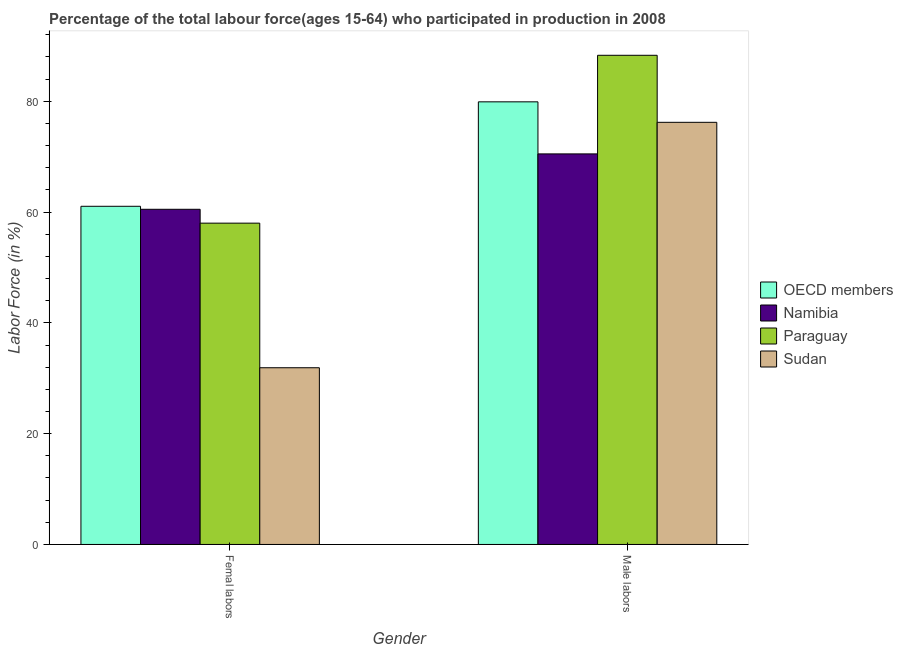How many groups of bars are there?
Provide a succinct answer. 2. Are the number of bars on each tick of the X-axis equal?
Your answer should be very brief. Yes. How many bars are there on the 1st tick from the left?
Ensure brevity in your answer.  4. What is the label of the 1st group of bars from the left?
Make the answer very short. Femal labors. What is the percentage of female labor force in Namibia?
Your response must be concise. 60.5. Across all countries, what is the maximum percentage of male labour force?
Ensure brevity in your answer.  88.3. Across all countries, what is the minimum percentage of female labor force?
Offer a very short reply. 31.9. In which country was the percentage of male labour force maximum?
Make the answer very short. Paraguay. In which country was the percentage of female labor force minimum?
Offer a very short reply. Sudan. What is the total percentage of female labor force in the graph?
Offer a terse response. 211.44. What is the difference between the percentage of male labour force in Namibia and that in OECD members?
Your answer should be very brief. -9.4. What is the difference between the percentage of male labour force in Paraguay and the percentage of female labor force in Namibia?
Your answer should be very brief. 27.8. What is the average percentage of male labour force per country?
Your answer should be compact. 78.72. What is the difference between the percentage of female labor force and percentage of male labour force in Namibia?
Your response must be concise. -10. What is the ratio of the percentage of female labor force in Sudan to that in Namibia?
Provide a succinct answer. 0.53. What does the 4th bar from the left in Male labors represents?
Offer a terse response. Sudan. What does the 3rd bar from the right in Male labors represents?
Ensure brevity in your answer.  Namibia. How many countries are there in the graph?
Provide a short and direct response. 4. What is the difference between two consecutive major ticks on the Y-axis?
Your answer should be very brief. 20. Where does the legend appear in the graph?
Offer a terse response. Center right. How many legend labels are there?
Make the answer very short. 4. What is the title of the graph?
Keep it short and to the point. Percentage of the total labour force(ages 15-64) who participated in production in 2008. What is the Labor Force (in %) in OECD members in Femal labors?
Make the answer very short. 61.04. What is the Labor Force (in %) in Namibia in Femal labors?
Your answer should be very brief. 60.5. What is the Labor Force (in %) in Sudan in Femal labors?
Provide a short and direct response. 31.9. What is the Labor Force (in %) in OECD members in Male labors?
Make the answer very short. 79.9. What is the Labor Force (in %) of Namibia in Male labors?
Offer a very short reply. 70.5. What is the Labor Force (in %) in Paraguay in Male labors?
Make the answer very short. 88.3. What is the Labor Force (in %) in Sudan in Male labors?
Offer a very short reply. 76.2. Across all Gender, what is the maximum Labor Force (in %) of OECD members?
Make the answer very short. 79.9. Across all Gender, what is the maximum Labor Force (in %) in Namibia?
Your response must be concise. 70.5. Across all Gender, what is the maximum Labor Force (in %) in Paraguay?
Provide a succinct answer. 88.3. Across all Gender, what is the maximum Labor Force (in %) of Sudan?
Keep it short and to the point. 76.2. Across all Gender, what is the minimum Labor Force (in %) in OECD members?
Make the answer very short. 61.04. Across all Gender, what is the minimum Labor Force (in %) in Namibia?
Keep it short and to the point. 60.5. Across all Gender, what is the minimum Labor Force (in %) of Paraguay?
Offer a very short reply. 58. Across all Gender, what is the minimum Labor Force (in %) of Sudan?
Ensure brevity in your answer.  31.9. What is the total Labor Force (in %) in OECD members in the graph?
Offer a very short reply. 140.94. What is the total Labor Force (in %) in Namibia in the graph?
Your answer should be compact. 131. What is the total Labor Force (in %) in Paraguay in the graph?
Your answer should be very brief. 146.3. What is the total Labor Force (in %) in Sudan in the graph?
Offer a very short reply. 108.1. What is the difference between the Labor Force (in %) in OECD members in Femal labors and that in Male labors?
Your answer should be very brief. -18.85. What is the difference between the Labor Force (in %) of Paraguay in Femal labors and that in Male labors?
Ensure brevity in your answer.  -30.3. What is the difference between the Labor Force (in %) in Sudan in Femal labors and that in Male labors?
Make the answer very short. -44.3. What is the difference between the Labor Force (in %) of OECD members in Femal labors and the Labor Force (in %) of Namibia in Male labors?
Provide a short and direct response. -9.46. What is the difference between the Labor Force (in %) in OECD members in Femal labors and the Labor Force (in %) in Paraguay in Male labors?
Provide a short and direct response. -27.26. What is the difference between the Labor Force (in %) in OECD members in Femal labors and the Labor Force (in %) in Sudan in Male labors?
Your answer should be compact. -15.16. What is the difference between the Labor Force (in %) of Namibia in Femal labors and the Labor Force (in %) of Paraguay in Male labors?
Your response must be concise. -27.8. What is the difference between the Labor Force (in %) in Namibia in Femal labors and the Labor Force (in %) in Sudan in Male labors?
Keep it short and to the point. -15.7. What is the difference between the Labor Force (in %) in Paraguay in Femal labors and the Labor Force (in %) in Sudan in Male labors?
Keep it short and to the point. -18.2. What is the average Labor Force (in %) of OECD members per Gender?
Keep it short and to the point. 70.47. What is the average Labor Force (in %) in Namibia per Gender?
Your response must be concise. 65.5. What is the average Labor Force (in %) in Paraguay per Gender?
Offer a very short reply. 73.15. What is the average Labor Force (in %) in Sudan per Gender?
Ensure brevity in your answer.  54.05. What is the difference between the Labor Force (in %) in OECD members and Labor Force (in %) in Namibia in Femal labors?
Keep it short and to the point. 0.54. What is the difference between the Labor Force (in %) in OECD members and Labor Force (in %) in Paraguay in Femal labors?
Keep it short and to the point. 3.04. What is the difference between the Labor Force (in %) of OECD members and Labor Force (in %) of Sudan in Femal labors?
Offer a terse response. 29.14. What is the difference between the Labor Force (in %) in Namibia and Labor Force (in %) in Sudan in Femal labors?
Ensure brevity in your answer.  28.6. What is the difference between the Labor Force (in %) of Paraguay and Labor Force (in %) of Sudan in Femal labors?
Provide a succinct answer. 26.1. What is the difference between the Labor Force (in %) in OECD members and Labor Force (in %) in Namibia in Male labors?
Offer a terse response. 9.4. What is the difference between the Labor Force (in %) of OECD members and Labor Force (in %) of Paraguay in Male labors?
Your answer should be compact. -8.4. What is the difference between the Labor Force (in %) of OECD members and Labor Force (in %) of Sudan in Male labors?
Your response must be concise. 3.7. What is the difference between the Labor Force (in %) of Namibia and Labor Force (in %) of Paraguay in Male labors?
Your answer should be very brief. -17.8. What is the difference between the Labor Force (in %) of Paraguay and Labor Force (in %) of Sudan in Male labors?
Offer a terse response. 12.1. What is the ratio of the Labor Force (in %) of OECD members in Femal labors to that in Male labors?
Offer a very short reply. 0.76. What is the ratio of the Labor Force (in %) of Namibia in Femal labors to that in Male labors?
Provide a short and direct response. 0.86. What is the ratio of the Labor Force (in %) of Paraguay in Femal labors to that in Male labors?
Provide a succinct answer. 0.66. What is the ratio of the Labor Force (in %) of Sudan in Femal labors to that in Male labors?
Ensure brevity in your answer.  0.42. What is the difference between the highest and the second highest Labor Force (in %) of OECD members?
Offer a terse response. 18.85. What is the difference between the highest and the second highest Labor Force (in %) of Paraguay?
Provide a short and direct response. 30.3. What is the difference between the highest and the second highest Labor Force (in %) in Sudan?
Your answer should be compact. 44.3. What is the difference between the highest and the lowest Labor Force (in %) in OECD members?
Keep it short and to the point. 18.85. What is the difference between the highest and the lowest Labor Force (in %) in Paraguay?
Provide a short and direct response. 30.3. What is the difference between the highest and the lowest Labor Force (in %) in Sudan?
Your answer should be compact. 44.3. 